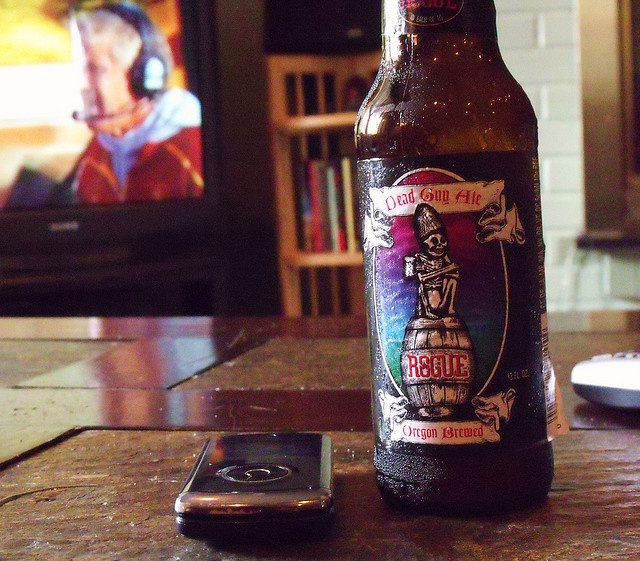Describe the objects in this image and their specific colors. I can see dining table in gold, gray, black, maroon, and brown tones, bottle in gold, black, maroon, white, and gray tones, tv in gold, ivory, black, khaki, and maroon tones, people in gold, white, maroon, brown, and lightpink tones, and cell phone in gold, black, maroon, gray, and brown tones in this image. 